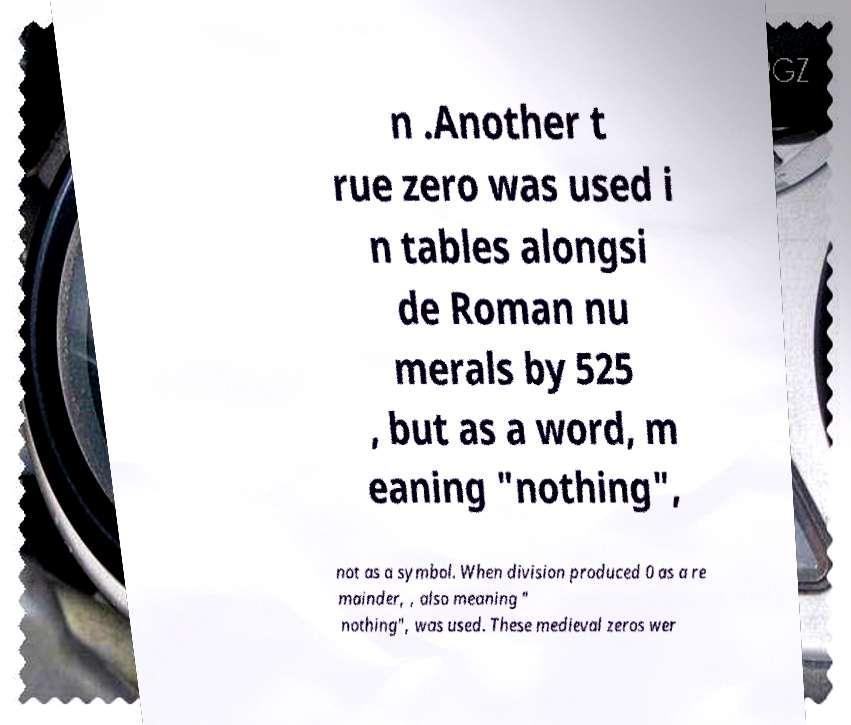I need the written content from this picture converted into text. Can you do that? n .Another t rue zero was used i n tables alongsi de Roman nu merals by 525 , but as a word, m eaning "nothing", not as a symbol. When division produced 0 as a re mainder, , also meaning " nothing", was used. These medieval zeros wer 